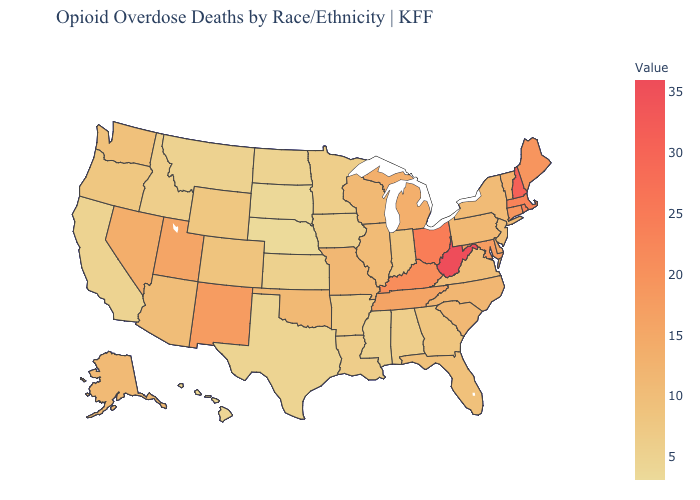Which states have the highest value in the USA?
Be succinct. West Virginia. Which states have the highest value in the USA?
Quick response, please. West Virginia. Among the states that border Missouri , does Oklahoma have the highest value?
Quick response, please. No. 